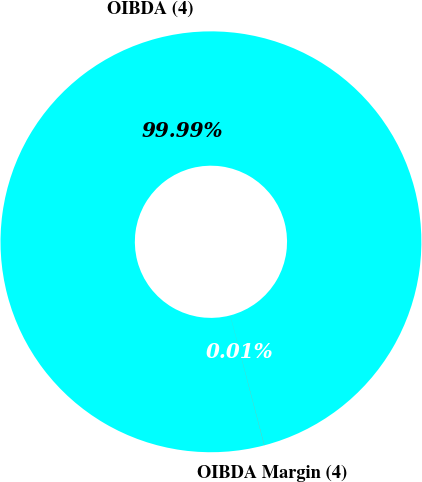<chart> <loc_0><loc_0><loc_500><loc_500><pie_chart><fcel>OIBDA (4)<fcel>OIBDA Margin (4)<nl><fcel>99.99%<fcel>0.01%<nl></chart> 